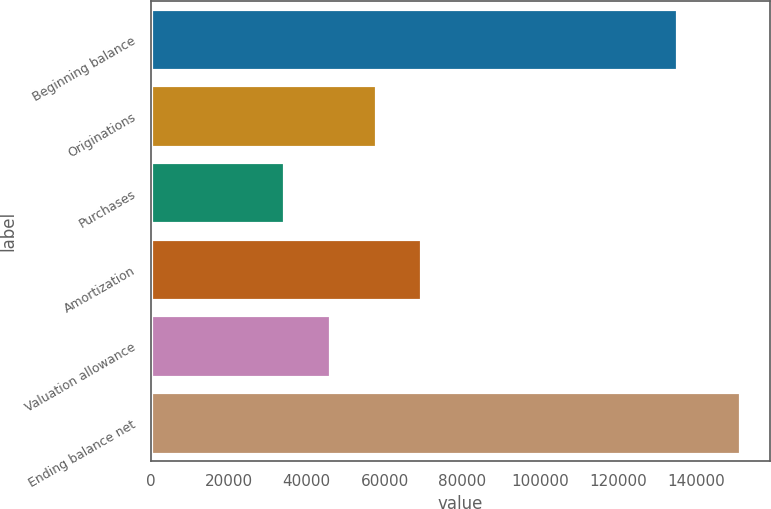<chart> <loc_0><loc_0><loc_500><loc_500><bar_chart><fcel>Beginning balance<fcel>Originations<fcel>Purchases<fcel>Amortization<fcel>Valuation allowance<fcel>Ending balance net<nl><fcel>135076<fcel>57657.6<fcel>34243<fcel>69364.9<fcel>45950.3<fcel>151316<nl></chart> 